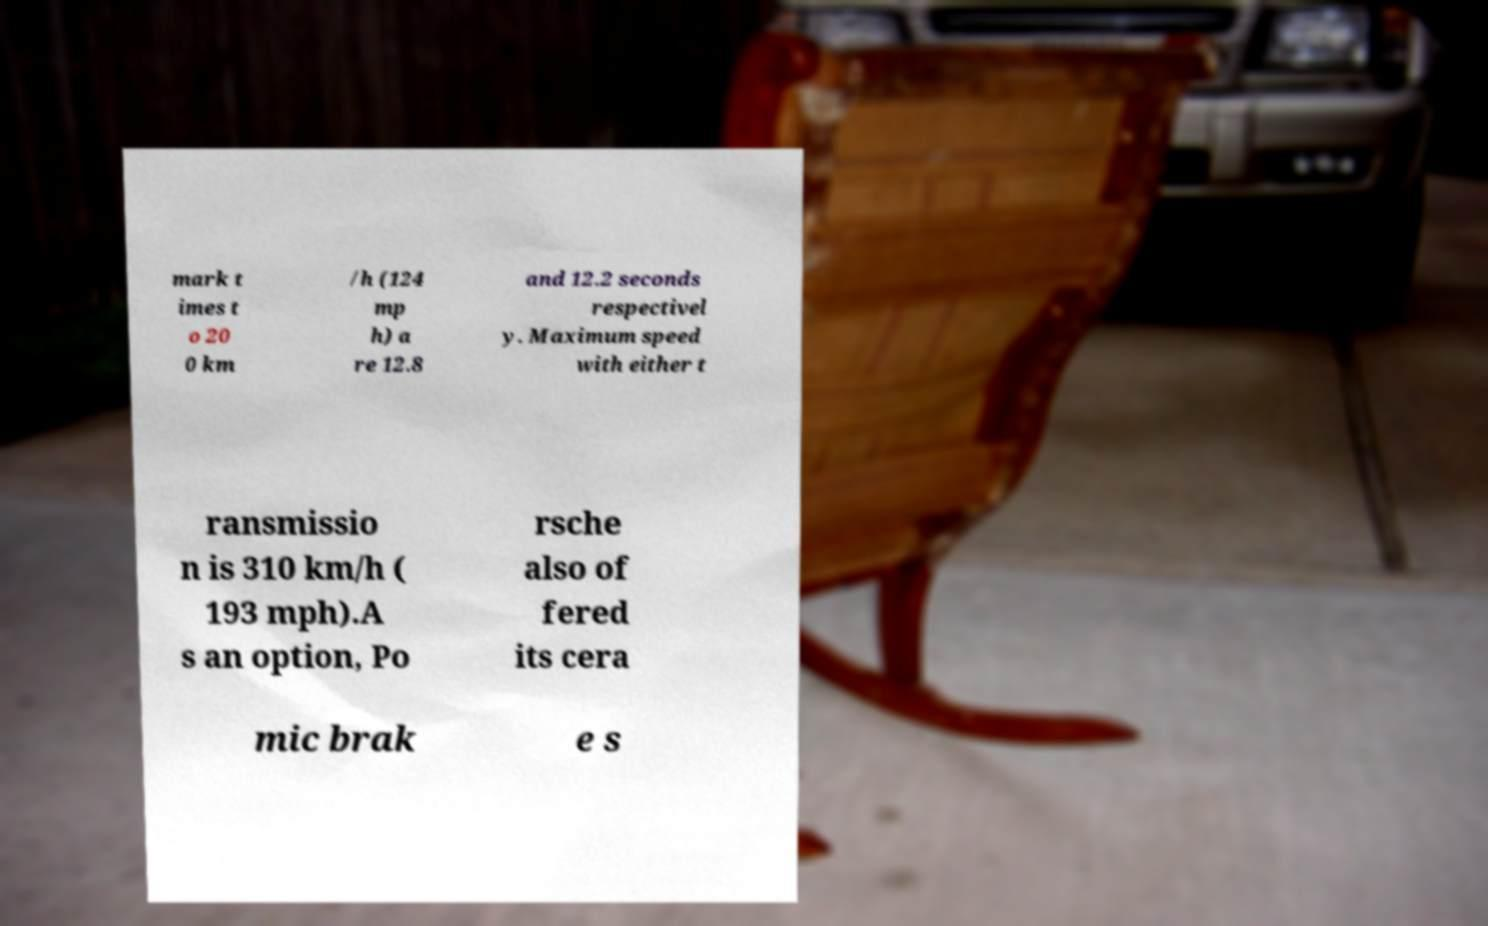There's text embedded in this image that I need extracted. Can you transcribe it verbatim? mark t imes t o 20 0 km /h (124 mp h) a re 12.8 and 12.2 seconds respectivel y. Maximum speed with either t ransmissio n is 310 km/h ( 193 mph).A s an option, Po rsche also of fered its cera mic brak e s 